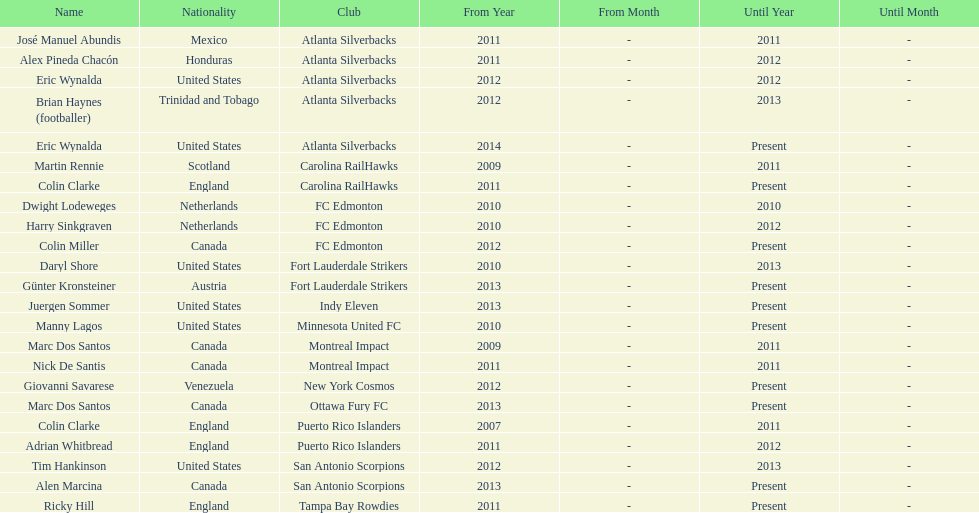What were all the coaches who were coaching in 2010? Martin Rennie, Dwight Lodeweges, Harry Sinkgraven, Daryl Shore, Manny Lagos, Marc Dos Santos, Colin Clarke. Which of the 2010 coaches were not born in north america? Martin Rennie, Dwight Lodeweges, Harry Sinkgraven, Colin Clarke. Which coaches that were coaching in 2010 and were not from north america did not coach for fc edmonton? Martin Rennie, Colin Clarke. What coach did not coach for fc edmonton in 2010 and was not north american nationality had the shortened career as a coach? Martin Rennie. 